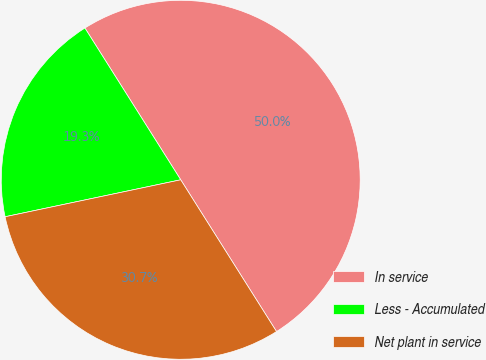Convert chart. <chart><loc_0><loc_0><loc_500><loc_500><pie_chart><fcel>In service<fcel>Less - Accumulated<fcel>Net plant in service<nl><fcel>50.0%<fcel>19.34%<fcel>30.66%<nl></chart> 